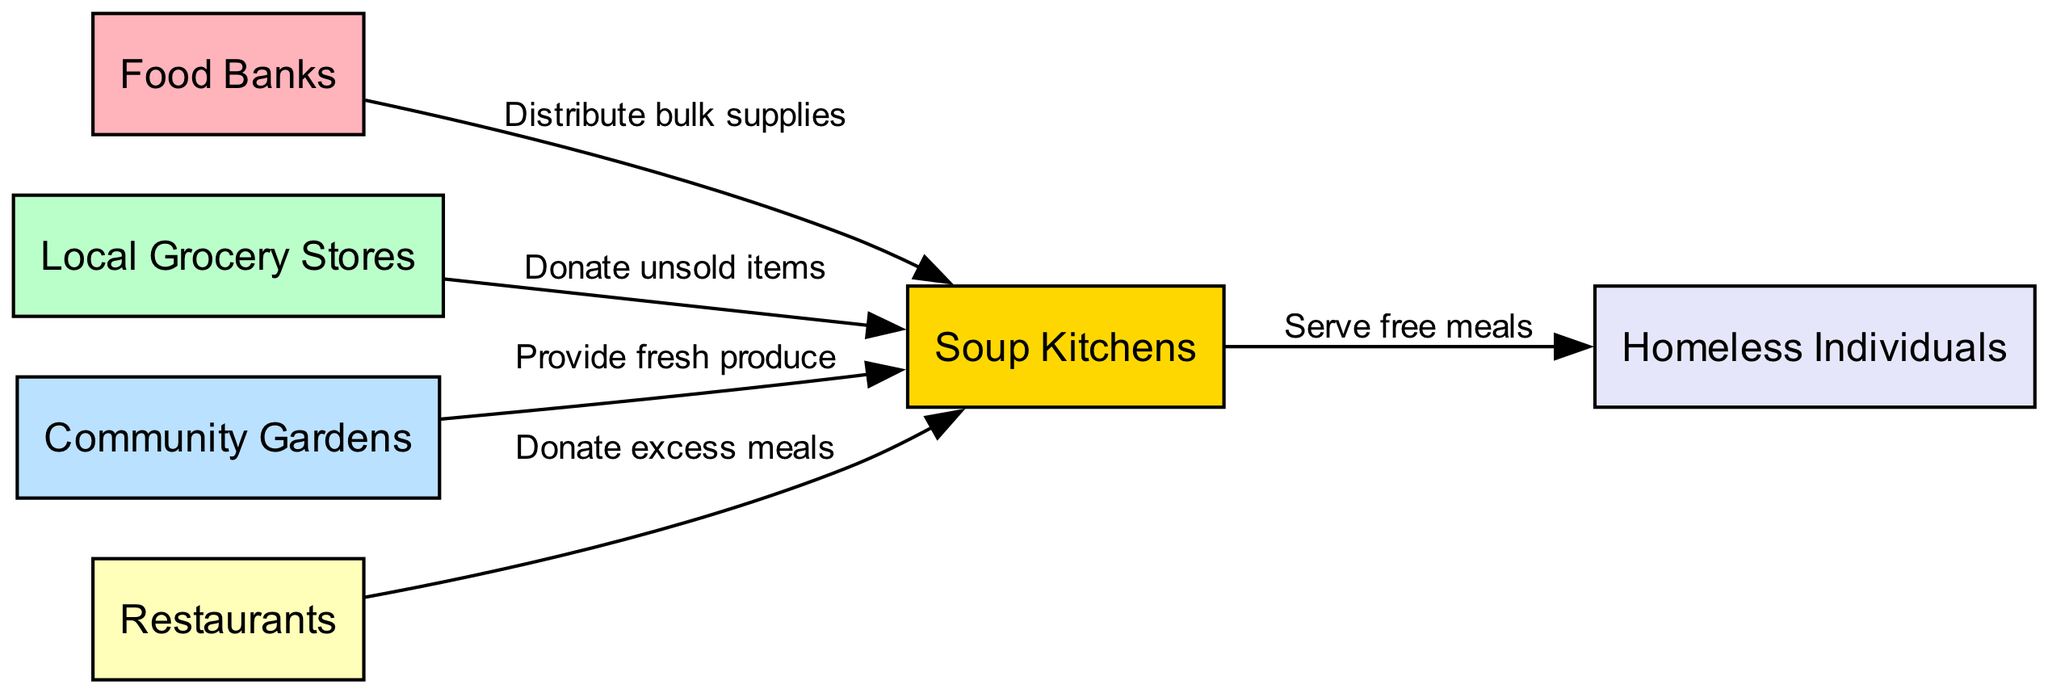What are the total number of nodes in this diagram? The nodes listed in the diagram are: Food Banks, Local Grocery Stores, Community Gardens, Restaurants, Soup Kitchens, and Homeless Individuals. Counting all these nodes gives a total of 6.
Answer: 6 Which node donates unsold items to Soup Kitchens? The diagram shows an edge from Local Grocery Stores to Soup Kitchens labeled "Donate unsold items." Thus, Local Grocery Stores is the node that is responsible for this action.
Answer: Local Grocery Stores What does Community Gardens provide to Soup Kitchens? According to the diagram, the edge from Community Gardens to Soup Kitchens is labeled "Provide fresh produce," indicating that this is what Community Gardens provides.
Answer: Fresh produce How many edges are in the diagram? The edges listed in the diagram are: 1) Food Banks to Soup Kitchens, 2) Local Grocery Stores to Soup Kitchens, 3) Community Gardens to Soup Kitchens, 4) Restaurants to Soup Kitchens, and 5) Soup Kitchens to Homeless Individuals. Counting these edges gives a total of 5.
Answer: 5 Which node serves free meals? The diagram shows that Soup Kitchens serve free meals to Homeless Individuals, as indicated by the edge with the label "Serve free meals" directed towards Homeless Individuals.
Answer: Soup Kitchens What kinds of entities donate to Soup Kitchens? The diagram indicates that Food Banks, Local Grocery Stores, Community Gardens, and Restaurants all donate items to Soup Kitchens, as evidenced by the respective edges labeled with different types of donations.
Answer: Food Banks, Local Grocery Stores, Community Gardens, Restaurants How does food reach Homeless Individuals in this network? To understand the flow, we start with the nodes that donate to Soup Kitchens (Food Banks, Local Grocery Stores, Community Gardens, Restaurants). These entities distribute food to Soup Kitchens, which in turn serve free meals to Homeless Individuals. Therefore, the food reaches Homeless Individuals through Soup Kitchens.
Answer: Through Soup Kitchens Which entity donates excess meals? The diagram specifies that Restaurants donate excess meals to Soup Kitchens. This is indicated by the edge going from Restaurants to Soup Kitchens labeled "Donate excess meals."
Answer: Restaurants What is the relationship between Food Banks and Soup Kitchens? The relationship is illustrated by an edge directed from Food Banks to Soup Kitchens, labeled "Distribute bulk supplies." This indicates that Food Banks distribute bulk supplies to Soup Kitchens.
Answer: Distribute bulk supplies 